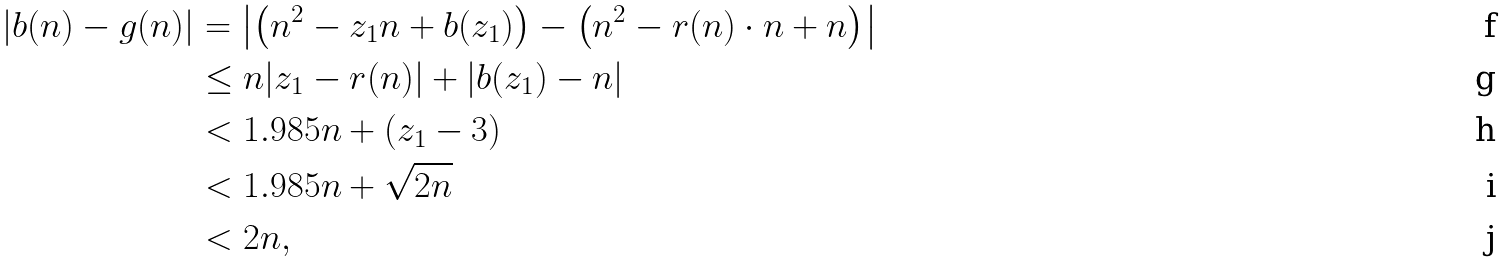Convert formula to latex. <formula><loc_0><loc_0><loc_500><loc_500>| b ( n ) - g ( n ) | & = \left | \left ( n ^ { 2 } - z _ { 1 } n + b ( z _ { 1 } ) \right ) - \left ( n ^ { 2 } - r ( n ) \cdot n + n \right ) \right | \\ & \leq n | z _ { 1 } - r ( n ) | + | b ( z _ { 1 } ) - n | \\ & < 1 . 9 8 5 n + ( z _ { 1 } - 3 ) \\ & < 1 . 9 8 5 n + \sqrt { 2 n } \\ & < 2 n ,</formula> 